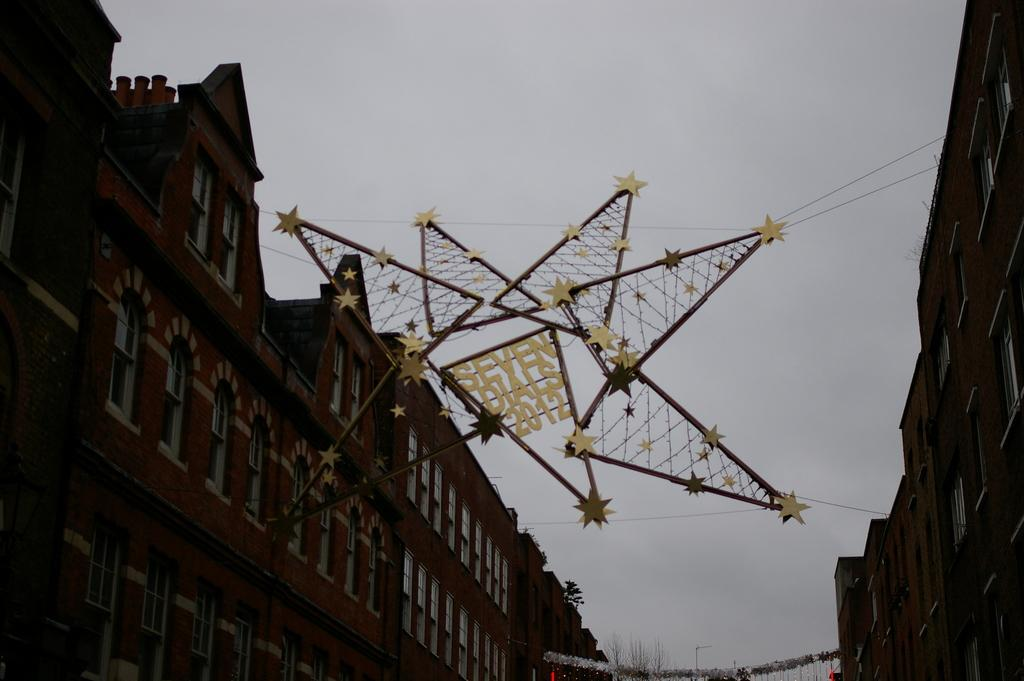What type of structures can be seen in the image? There are buildings with windows in the image. Can you describe any additional features between the buildings? Yes, there is a decorative item hanging between the buildings. What part of the natural environment is visible in the image? The sky is visible in the image. What type of chairs are being offered in the image? There are no chairs present in the image. What story is being told by the decorative item in the image? The decorative item in the image does not tell a story; it is simply a decorative element between the buildings. 